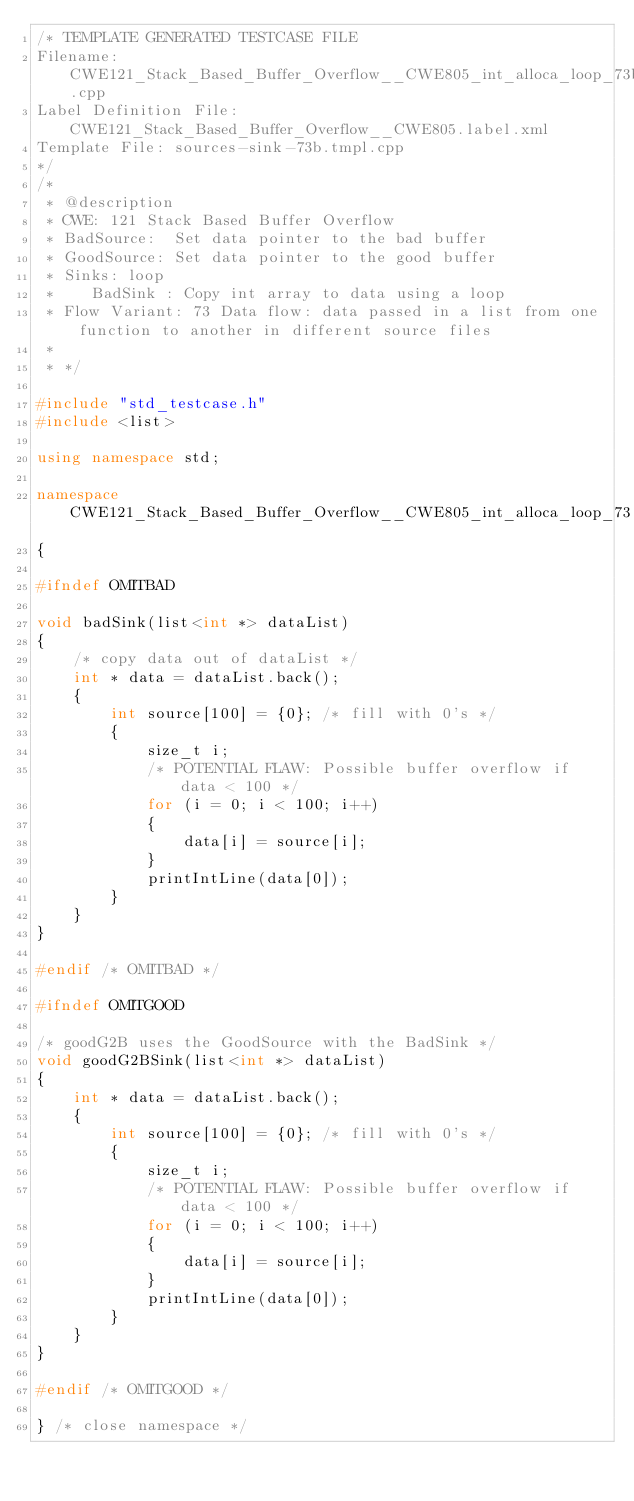<code> <loc_0><loc_0><loc_500><loc_500><_C++_>/* TEMPLATE GENERATED TESTCASE FILE
Filename: CWE121_Stack_Based_Buffer_Overflow__CWE805_int_alloca_loop_73b.cpp
Label Definition File: CWE121_Stack_Based_Buffer_Overflow__CWE805.label.xml
Template File: sources-sink-73b.tmpl.cpp
*/
/*
 * @description
 * CWE: 121 Stack Based Buffer Overflow
 * BadSource:  Set data pointer to the bad buffer
 * GoodSource: Set data pointer to the good buffer
 * Sinks: loop
 *    BadSink : Copy int array to data using a loop
 * Flow Variant: 73 Data flow: data passed in a list from one function to another in different source files
 *
 * */

#include "std_testcase.h"
#include <list>

using namespace std;

namespace CWE121_Stack_Based_Buffer_Overflow__CWE805_int_alloca_loop_73
{

#ifndef OMITBAD

void badSink(list<int *> dataList)
{
    /* copy data out of dataList */
    int * data = dataList.back();
    {
        int source[100] = {0}; /* fill with 0's */
        {
            size_t i;
            /* POTENTIAL FLAW: Possible buffer overflow if data < 100 */
            for (i = 0; i < 100; i++)
            {
                data[i] = source[i];
            }
            printIntLine(data[0]);
        }
    }
}

#endif /* OMITBAD */

#ifndef OMITGOOD

/* goodG2B uses the GoodSource with the BadSink */
void goodG2BSink(list<int *> dataList)
{
    int * data = dataList.back();
    {
        int source[100] = {0}; /* fill with 0's */
        {
            size_t i;
            /* POTENTIAL FLAW: Possible buffer overflow if data < 100 */
            for (i = 0; i < 100; i++)
            {
                data[i] = source[i];
            }
            printIntLine(data[0]);
        }
    }
}

#endif /* OMITGOOD */

} /* close namespace */
</code> 